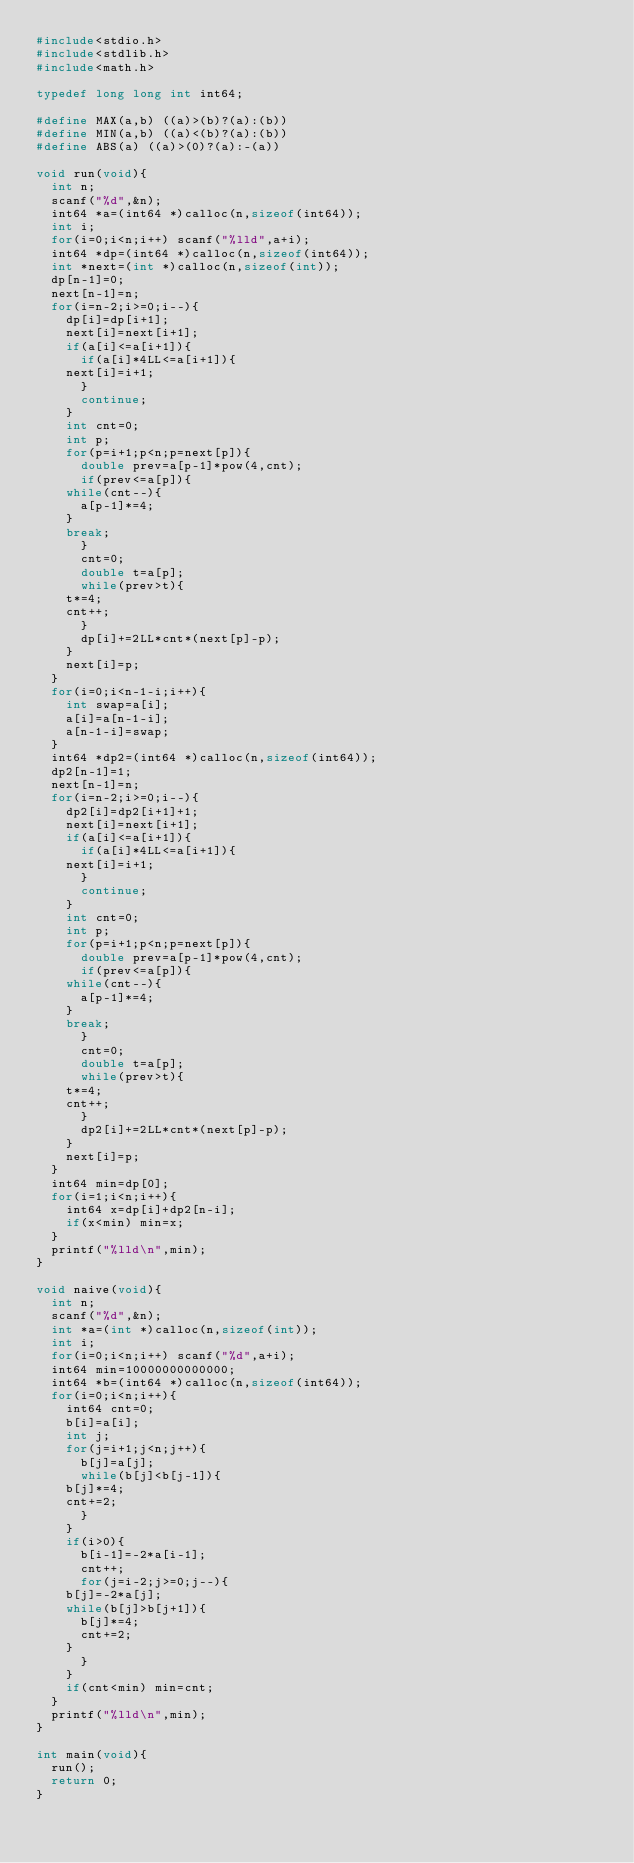Convert code to text. <code><loc_0><loc_0><loc_500><loc_500><_C_>#include<stdio.h>
#include<stdlib.h>
#include<math.h>

typedef long long int int64;

#define MAX(a,b) ((a)>(b)?(a):(b))
#define MIN(a,b) ((a)<(b)?(a):(b))
#define ABS(a) ((a)>(0)?(a):-(a))

void run(void){
  int n;
  scanf("%d",&n);
  int64 *a=(int64 *)calloc(n,sizeof(int64));
  int i;
  for(i=0;i<n;i++) scanf("%lld",a+i);
  int64 *dp=(int64 *)calloc(n,sizeof(int64));
  int *next=(int *)calloc(n,sizeof(int));
  dp[n-1]=0;
  next[n-1]=n;
  for(i=n-2;i>=0;i--){
    dp[i]=dp[i+1];
    next[i]=next[i+1];
    if(a[i]<=a[i+1]){
      if(a[i]*4LL<=a[i+1]){
	next[i]=i+1;
      }
      continue;
    }
    int cnt=0;
    int p;
    for(p=i+1;p<n;p=next[p]){
      double prev=a[p-1]*pow(4,cnt);
      if(prev<=a[p]){
	while(cnt--){
	  a[p-1]*=4;
	}
	break;
      }
      cnt=0;
      double t=a[p];
      while(prev>t){
	t*=4;
	cnt++;
      }
      dp[i]+=2LL*cnt*(next[p]-p);
    }
    next[i]=p;
  }
  for(i=0;i<n-1-i;i++){
    int swap=a[i];
    a[i]=a[n-1-i];
    a[n-1-i]=swap;
  }
  int64 *dp2=(int64 *)calloc(n,sizeof(int64));
  dp2[n-1]=1;
  next[n-1]=n;
  for(i=n-2;i>=0;i--){
    dp2[i]=dp2[i+1]+1;
    next[i]=next[i+1];
    if(a[i]<=a[i+1]){
      if(a[i]*4LL<=a[i+1]){
	next[i]=i+1;
      }
      continue;
    }
    int cnt=0;
    int p;
    for(p=i+1;p<n;p=next[p]){
      double prev=a[p-1]*pow(4,cnt);
      if(prev<=a[p]){
	while(cnt--){
	  a[p-1]*=4;
	}
	break;
      }
      cnt=0;
      double t=a[p];
      while(prev>t){
	t*=4;
	cnt++;
      }
      dp2[i]+=2LL*cnt*(next[p]-p);
    }
    next[i]=p;
  }
  int64 min=dp[0];
  for(i=1;i<n;i++){
    int64 x=dp[i]+dp2[n-i];
    if(x<min) min=x;
  }
  printf("%lld\n",min);
}

void naive(void){
  int n;
  scanf("%d",&n);
  int *a=(int *)calloc(n,sizeof(int));
  int i;
  for(i=0;i<n;i++) scanf("%d",a+i);
  int64 min=10000000000000;
  int64 *b=(int64 *)calloc(n,sizeof(int64));
  for(i=0;i<n;i++){
    int64 cnt=0;
    b[i]=a[i];
    int j;
    for(j=i+1;j<n;j++){
      b[j]=a[j];
      while(b[j]<b[j-1]){
	b[j]*=4;
	cnt+=2;
      }
    }
    if(i>0){
      b[i-1]=-2*a[i-1];
      cnt++;
      for(j=i-2;j>=0;j--){
	b[j]=-2*a[j];
	while(b[j]>b[j+1]){
	  b[j]*=4;
	  cnt+=2;
	}
      }
    }
    if(cnt<min) min=cnt;
  }
  printf("%lld\n",min);
}

int main(void){
  run();
  return 0;
}
</code> 